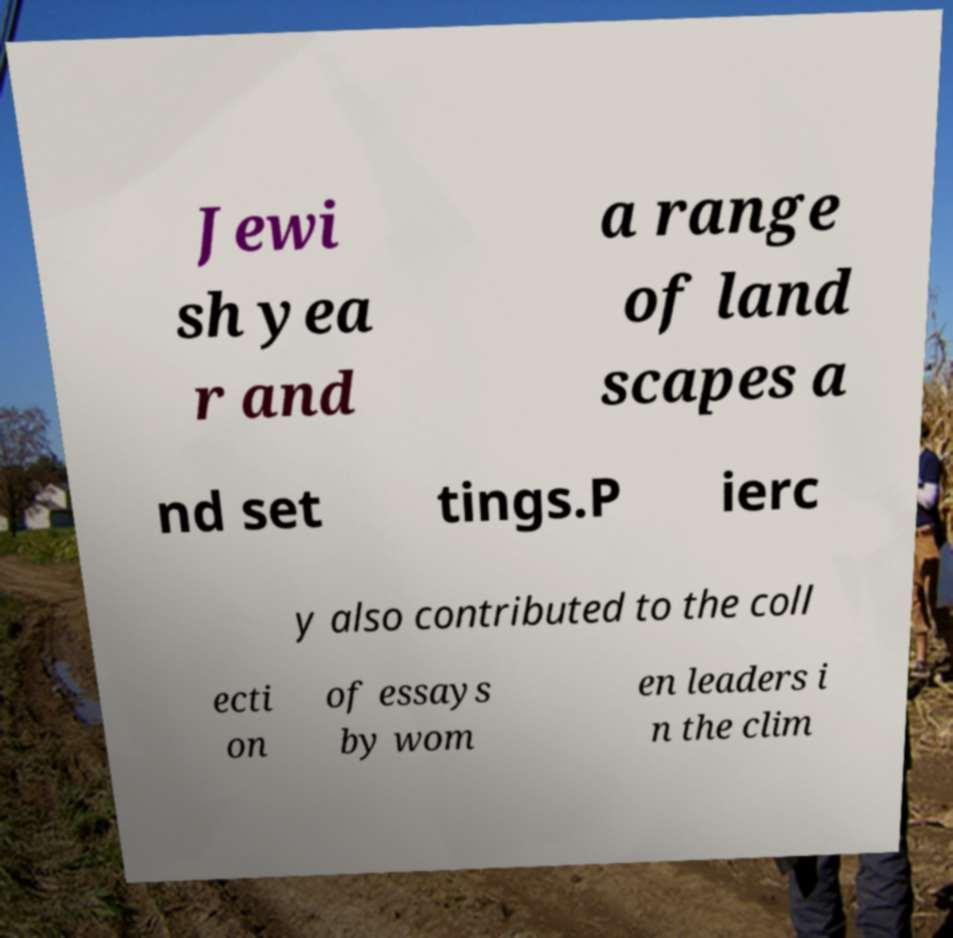For documentation purposes, I need the text within this image transcribed. Could you provide that? Jewi sh yea r and a range of land scapes a nd set tings.P ierc y also contributed to the coll ecti on of essays by wom en leaders i n the clim 